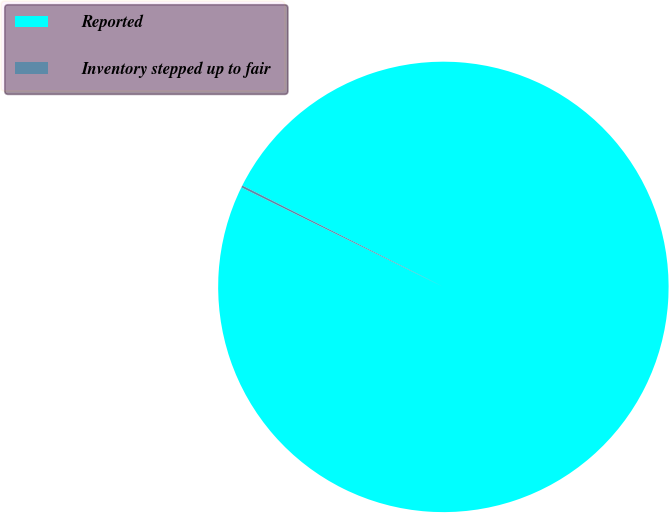Convert chart. <chart><loc_0><loc_0><loc_500><loc_500><pie_chart><fcel>Reported<fcel>Inventory stepped up to fair<nl><fcel>99.85%<fcel>0.15%<nl></chart> 